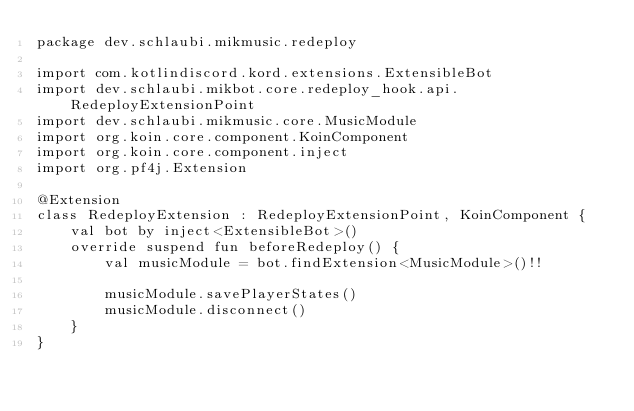<code> <loc_0><loc_0><loc_500><loc_500><_Kotlin_>package dev.schlaubi.mikmusic.redeploy

import com.kotlindiscord.kord.extensions.ExtensibleBot
import dev.schlaubi.mikbot.core.redeploy_hook.api.RedeployExtensionPoint
import dev.schlaubi.mikmusic.core.MusicModule
import org.koin.core.component.KoinComponent
import org.koin.core.component.inject
import org.pf4j.Extension

@Extension
class RedeployExtension : RedeployExtensionPoint, KoinComponent {
    val bot by inject<ExtensibleBot>()
    override suspend fun beforeRedeploy() {
        val musicModule = bot.findExtension<MusicModule>()!!

        musicModule.savePlayerStates()
        musicModule.disconnect()
    }
}
</code> 